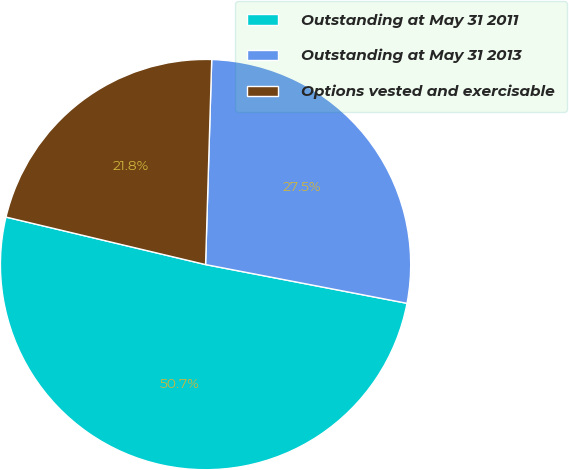<chart> <loc_0><loc_0><loc_500><loc_500><pie_chart><fcel>Outstanding at May 31 2011<fcel>Outstanding at May 31 2013<fcel>Options vested and exercisable<nl><fcel>50.7%<fcel>27.55%<fcel>21.76%<nl></chart> 